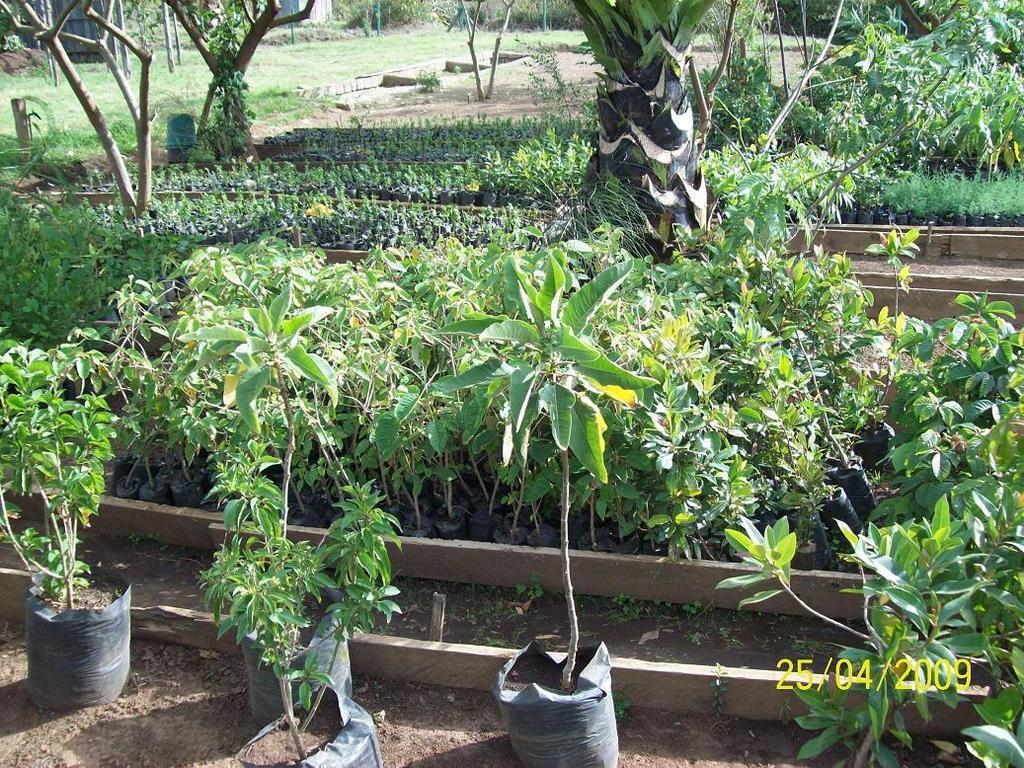How would you summarize this image in a sentence or two? At the bottom of the picture, we see plants and there are many trees in the background. We even see a white color building. This picture might be clicked in a plant nursery and it is a sunny day. 